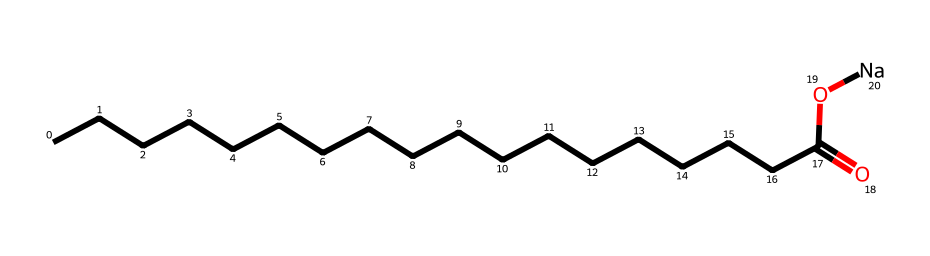What is the molecular formula of this chemical? The SMILES representation suggests it comprises a long hydrocarbon chain and a carboxylic acid functional group, with sodium as a counter ion. The longest carbon chain contains 18 carbon atoms, and there’s one carboxylate group along with one sodium atom, leading to the molecular formula C18H36O2Na.
Answer: C18H36O2Na How many carbon atoms are present in this structure? By analyzing the SMILES representation, we see that there is a hydrocarbon chain marked by the repeated 'C' characters, indicating that there are 18 carbon atoms in total.
Answer: 18 What type of functional group is present in this chemical? The structure contains a carboxylate ion, indicated by the presence of 'C(=O)O' in the SMILES representation, showing the carboxylic acid's double bond to oxygen and the single bond to a sodium atom.
Answer: carboxylate Why is sodium present in this chemical structure? Sodium is present to neutralize the negative charge of the carboxylate group, which occurs when a carboxylic acid loses a proton, allowing for the formation of soap from animal fat. In this case, sodium serves as the counter ion to create a sodium salt of the fatty acid.
Answer: to neutralize charge What does the long hydrocarbon chain indicate about the soap? The long hydrocarbon chain of 18 carbon atoms suggests that this soap has good emulsifying properties, providing hydrophobic characteristics that allow it to interact effectively with oils and dirt, enabling the removal of unwanted substances.
Answer: good emulsifying properties How does the structure influence its detergent ability? The long hydrocarbon tail provides a hydrophobic end, while the ionic head (sodium carboxylate) is hydrophilic. This duality allows the soap to interact with grease and water simultaneously, thus functioning as an effective detergent for cleaning.
Answer: duality allows effective cleaning 